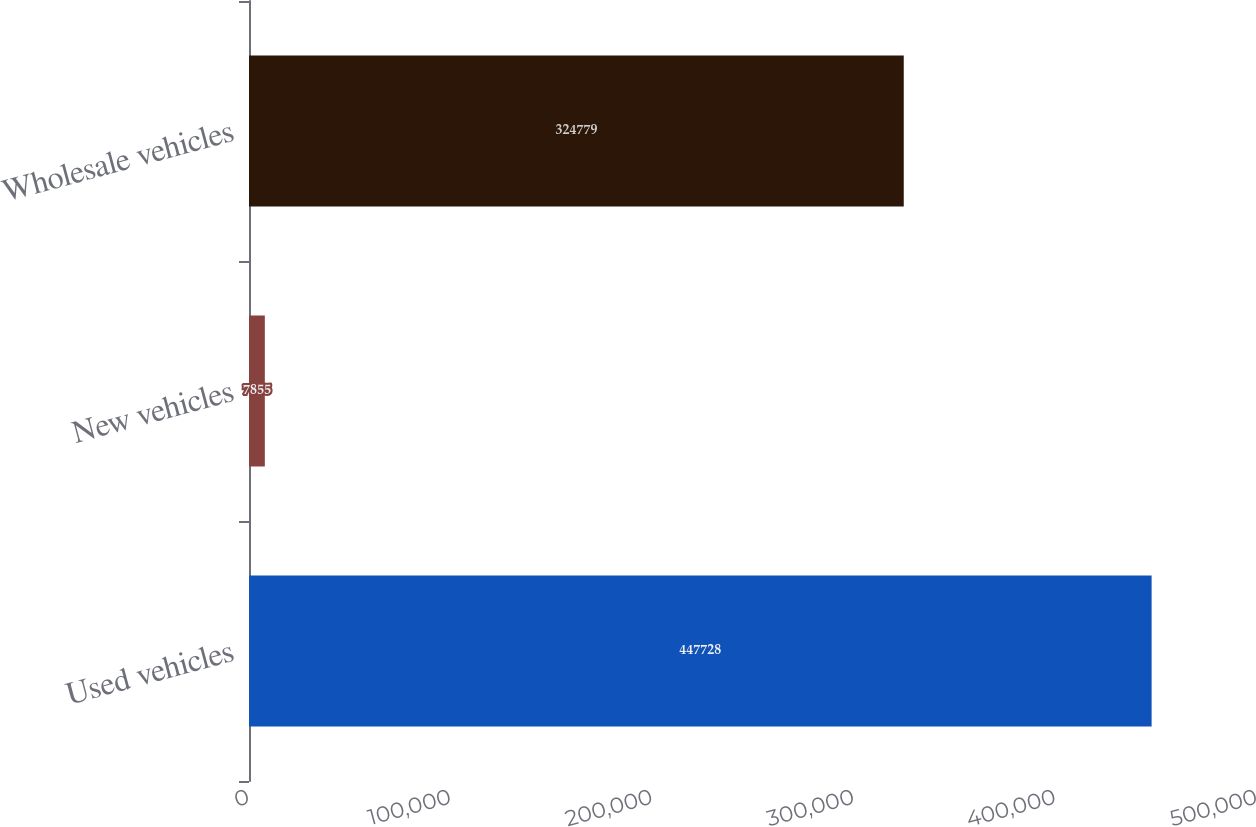Convert chart. <chart><loc_0><loc_0><loc_500><loc_500><bar_chart><fcel>Used vehicles<fcel>New vehicles<fcel>Wholesale vehicles<nl><fcel>447728<fcel>7855<fcel>324779<nl></chart> 